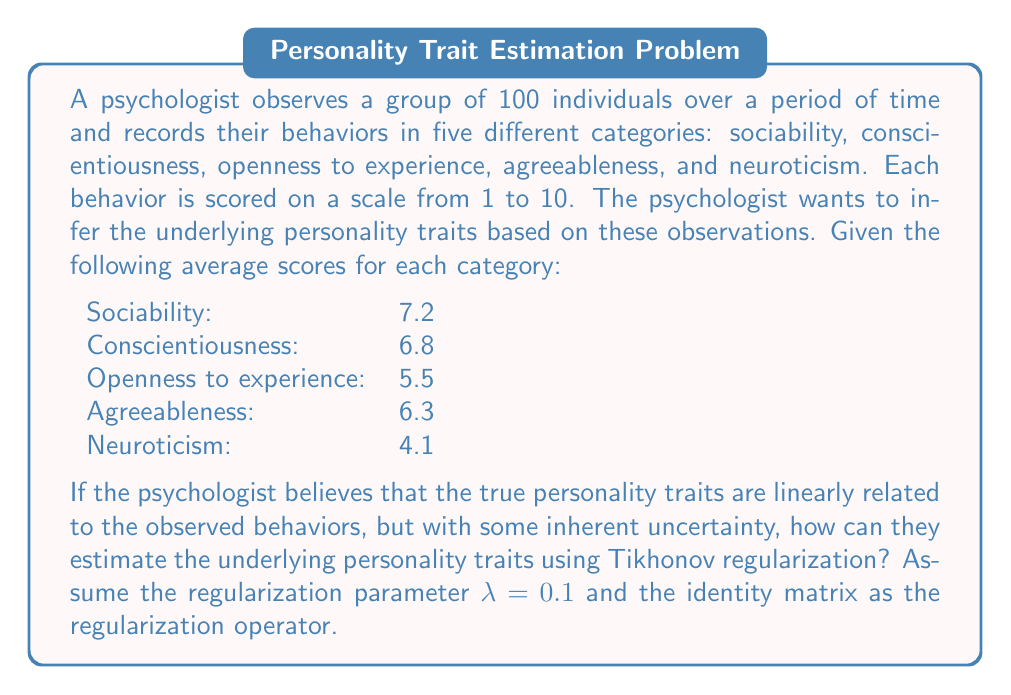Show me your answer to this math problem. To estimate the underlying personality traits using Tikhonov regularization, we need to follow these steps:

1. Set up the linear system:
   Let $\mathbf{x}$ be the vector of true personality traits and $\mathbf{b}$ be the vector of observed average scores. We assume $\mathbf{Ax} = \mathbf{b}$, where $\mathbf{A}$ is the identity matrix in this case.

2. Apply Tikhonov regularization:
   The regularized solution is given by:
   $$\mathbf{x}_{\text{reg}} = (\mathbf{A}^T\mathbf{A} + \lambda \mathbf{I})^{-1}\mathbf{A}^T\mathbf{b}$$
   where $\lambda$ is the regularization parameter and $\mathbf{I}$ is the identity matrix.

3. Substitute the given values:
   $\lambda = 0.1$
   $\mathbf{A} = \mathbf{I}$ (5x5 identity matrix)
   $\mathbf{b} = [7.2, 6.8, 5.5, 6.3, 4.1]^T$

4. Compute the regularized solution:
   $$\mathbf{x}_{\text{reg}} = (\mathbf{I}^T\mathbf{I} + 0.1\mathbf{I})^{-1}\mathbf{I}^T\mathbf{b}$$
   $$= (1.1\mathbf{I})^{-1}\mathbf{b}$$
   $$= \frac{1}{1.1}\mathbf{b}$$

5. Calculate the final result:
   $$\mathbf{x}_{\text{reg}} = \frac{1}{1.1}[7.2, 6.8, 5.5, 6.3, 4.1]^T$$
   $$= [6.55, 6.18, 5.00, 5.73, 3.73]^T$$

The resulting vector represents the estimated underlying personality traits for sociability, conscientiousness, openness to experience, agreeableness, and neuroticism, respectively.
Answer: $[6.55, 6.18, 5.00, 5.73, 3.73]^T$ 